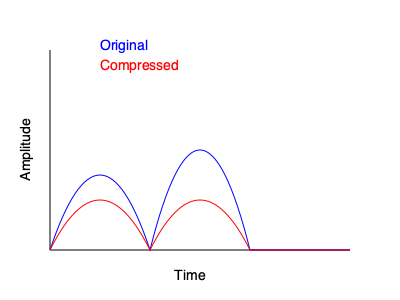As a DJ and audio shop owner, you're explaining audio compression to a customer. The graph shows an original audio waveform (blue) and its compressed version (red). What specific compression technique is demonstrated here, and how does it affect the dynamic range of the audio signal? To answer this question, let's analyze the graph step-by-step:

1. Observe the waveforms:
   - The blue line represents the original audio signal.
   - The red line represents the compressed audio signal.

2. Compare the peaks:
   - The original signal has higher peaks.
   - The compressed signal's peaks are reduced.

3. Compare the troughs:
   - The original signal has deeper troughs.
   - The compressed signal's troughs are less pronounced.

4. Analyze the overall shape:
   - The compressed signal appears "flattened" compared to the original.
   - The difference between the highest and lowest points is reduced.

5. Identify the compression technique:
   - This graph demonstrates "downward compression."
   - Downward compression reduces the level of signals above a certain threshold.

6. Effect on dynamic range:
   - Dynamic range is the difference between the loudest and quietest parts of an audio signal.
   - The compression has reduced the overall dynamic range.
   - The louder parts (peaks) are attenuated more than the quieter parts.

7. Purpose of this compression:
   - It makes the overall signal more consistent in volume.
   - It can increase the perceived loudness without increasing the peak level.

This type of compression is commonly used in electronic music production and DJing to create a more consistent and impactful sound, especially in club environments.
Answer: Downward compression, reducing dynamic range 